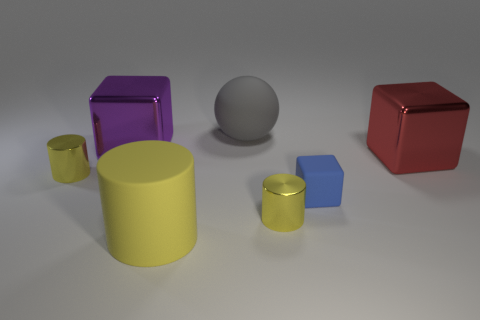There is a purple metal cube; what number of blue objects are behind it? 0 